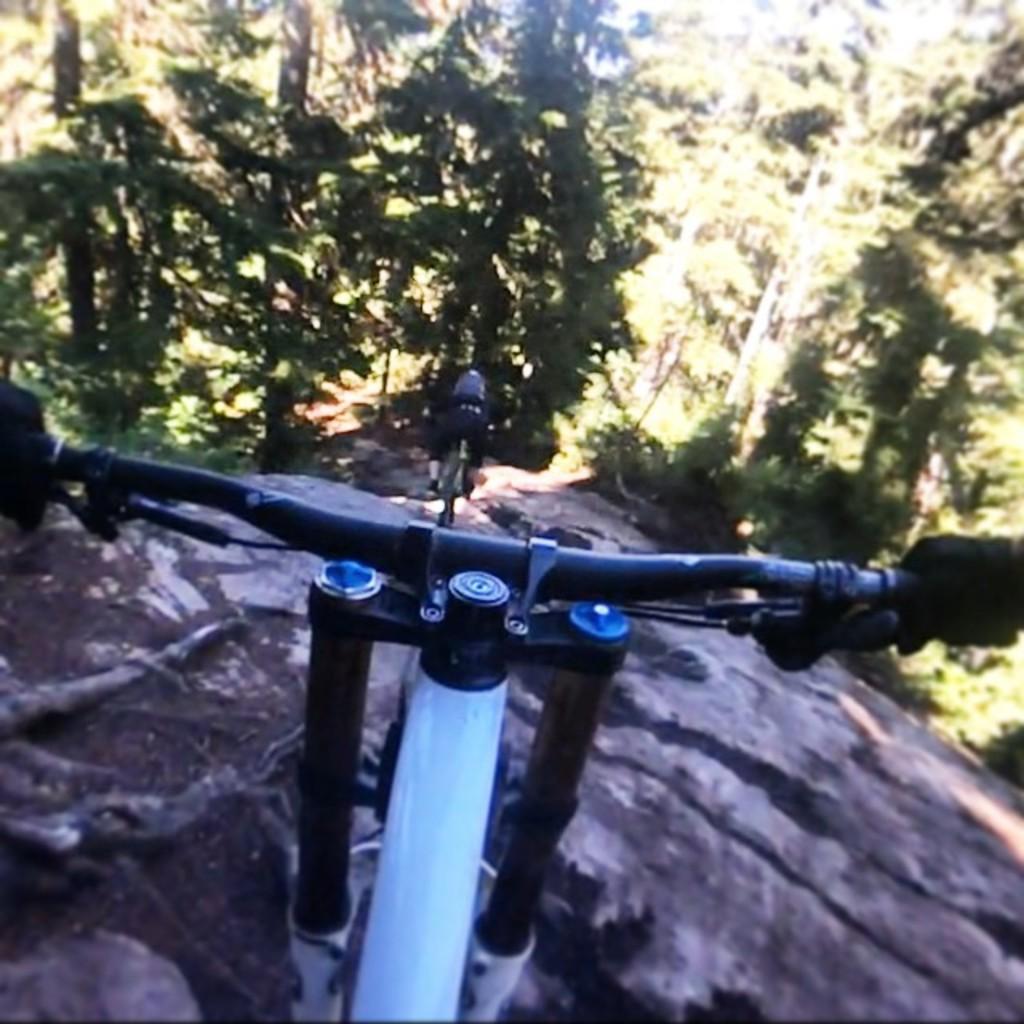Could you give a brief overview of what you see in this image? In this image I can see a portion of the bicycle at the bottom of the image on a mountain. At the top of the image I can see trees. 